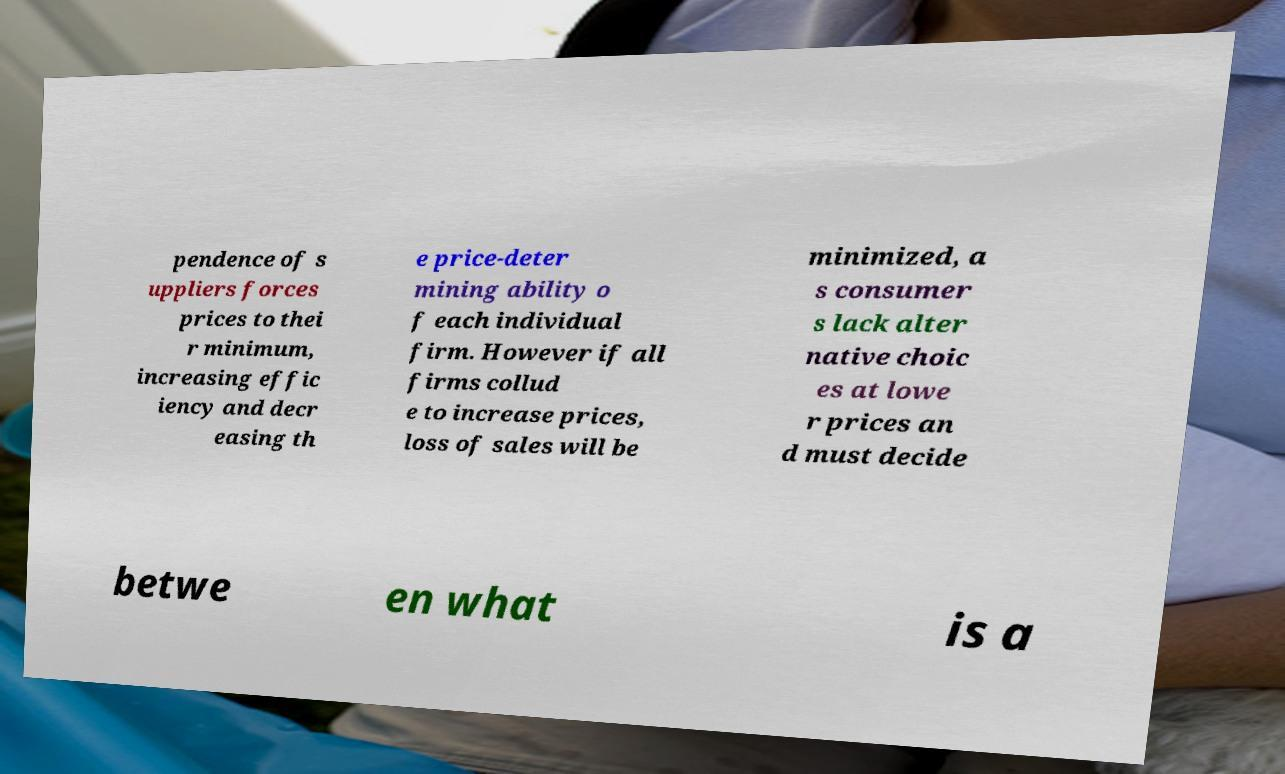Please read and relay the text visible in this image. What does it say? pendence of s uppliers forces prices to thei r minimum, increasing effic iency and decr easing th e price-deter mining ability o f each individual firm. However if all firms collud e to increase prices, loss of sales will be minimized, a s consumer s lack alter native choic es at lowe r prices an d must decide betwe en what is a 